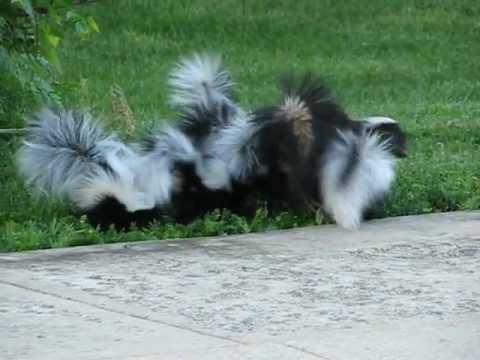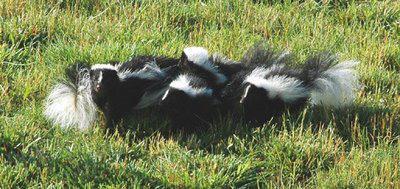The first image is the image on the left, the second image is the image on the right. Analyze the images presented: Is the assertion "The three skunks on the right are sitting side-by-side in the grass." valid? Answer yes or no. Yes. The first image is the image on the left, the second image is the image on the right. For the images shown, is this caption "The skunks in the right image have their tails up." true? Answer yes or no. No. 